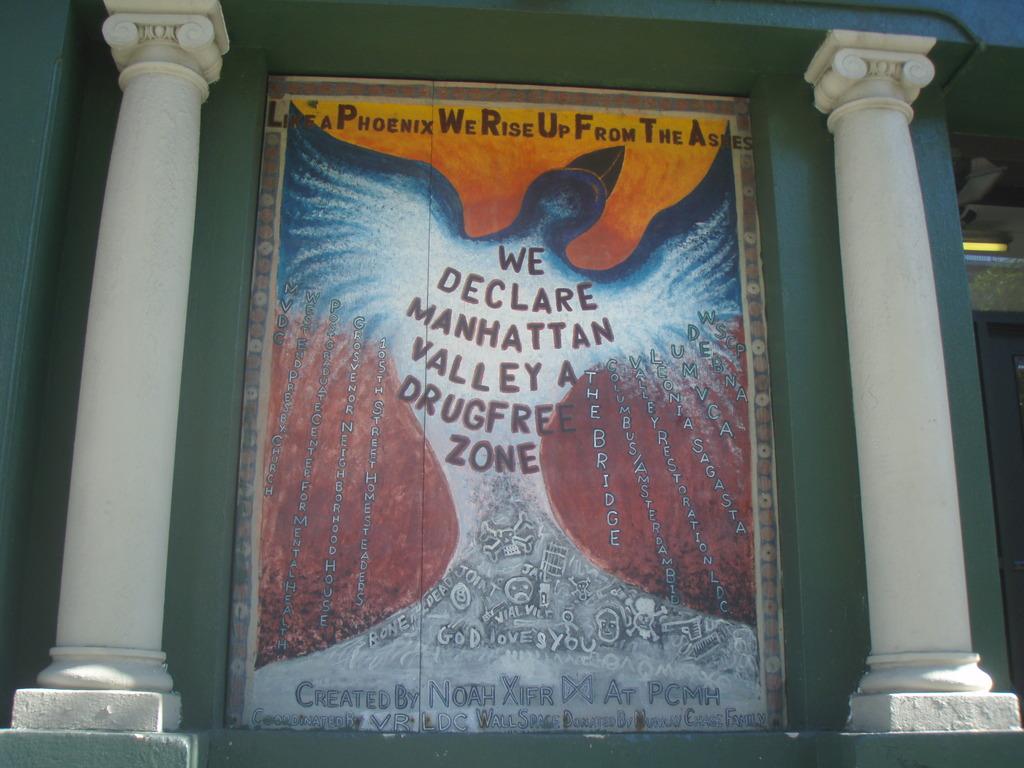What area is declared a drug free zone?
Ensure brevity in your answer.  Manhattan valley. Manhattan valley is the drug-free zone?
Keep it short and to the point. Yes. 